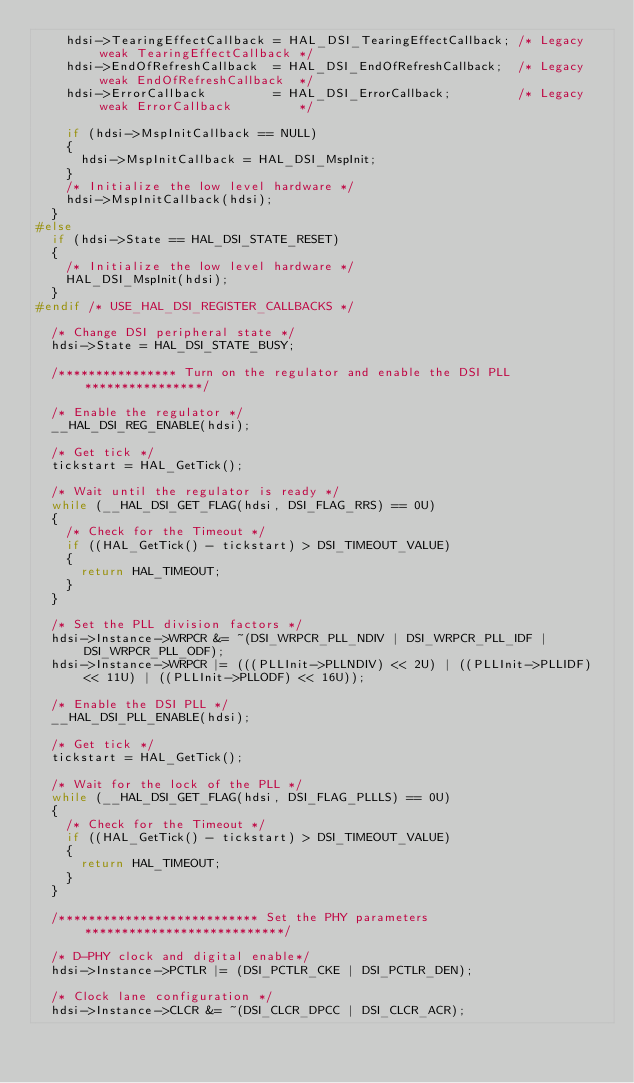Convert code to text. <code><loc_0><loc_0><loc_500><loc_500><_C_>    hdsi->TearingEffectCallback = HAL_DSI_TearingEffectCallback; /* Legacy weak TearingEffectCallback */
    hdsi->EndOfRefreshCallback  = HAL_DSI_EndOfRefreshCallback;  /* Legacy weak EndOfRefreshCallback  */
    hdsi->ErrorCallback         = HAL_DSI_ErrorCallback;         /* Legacy weak ErrorCallback         */

    if (hdsi->MspInitCallback == NULL)
    {
      hdsi->MspInitCallback = HAL_DSI_MspInit;
    }
    /* Initialize the low level hardware */
    hdsi->MspInitCallback(hdsi);
  }
#else
  if (hdsi->State == HAL_DSI_STATE_RESET)
  {
    /* Initialize the low level hardware */
    HAL_DSI_MspInit(hdsi);
  }
#endif /* USE_HAL_DSI_REGISTER_CALLBACKS */

  /* Change DSI peripheral state */
  hdsi->State = HAL_DSI_STATE_BUSY;

  /**************** Turn on the regulator and enable the DSI PLL ****************/

  /* Enable the regulator */
  __HAL_DSI_REG_ENABLE(hdsi);

  /* Get tick */
  tickstart = HAL_GetTick();

  /* Wait until the regulator is ready */
  while (__HAL_DSI_GET_FLAG(hdsi, DSI_FLAG_RRS) == 0U)
  {
    /* Check for the Timeout */
    if ((HAL_GetTick() - tickstart) > DSI_TIMEOUT_VALUE)
    {
      return HAL_TIMEOUT;
    }
  }

  /* Set the PLL division factors */
  hdsi->Instance->WRPCR &= ~(DSI_WRPCR_PLL_NDIV | DSI_WRPCR_PLL_IDF | DSI_WRPCR_PLL_ODF);
  hdsi->Instance->WRPCR |= (((PLLInit->PLLNDIV) << 2U) | ((PLLInit->PLLIDF) << 11U) | ((PLLInit->PLLODF) << 16U));

  /* Enable the DSI PLL */
  __HAL_DSI_PLL_ENABLE(hdsi);

  /* Get tick */
  tickstart = HAL_GetTick();

  /* Wait for the lock of the PLL */
  while (__HAL_DSI_GET_FLAG(hdsi, DSI_FLAG_PLLLS) == 0U)
  {
    /* Check for the Timeout */
    if ((HAL_GetTick() - tickstart) > DSI_TIMEOUT_VALUE)
    {
      return HAL_TIMEOUT;
    }
  }

  /*************************** Set the PHY parameters ***************************/

  /* D-PHY clock and digital enable*/
  hdsi->Instance->PCTLR |= (DSI_PCTLR_CKE | DSI_PCTLR_DEN);

  /* Clock lane configuration */
  hdsi->Instance->CLCR &= ~(DSI_CLCR_DPCC | DSI_CLCR_ACR);</code> 